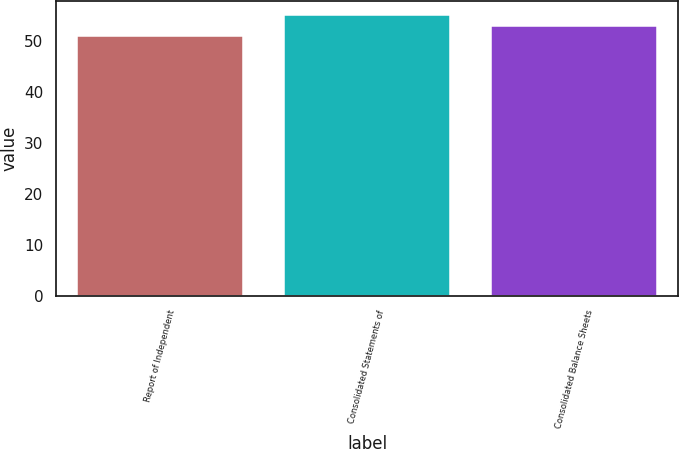Convert chart. <chart><loc_0><loc_0><loc_500><loc_500><bar_chart><fcel>Report of Independent<fcel>Consolidated Statements of<fcel>Consolidated Balance Sheets<nl><fcel>51<fcel>55<fcel>53<nl></chart> 